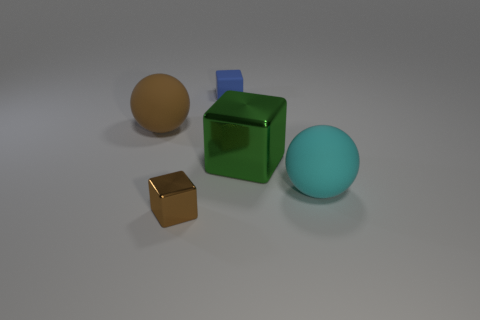Subtract all spheres. How many objects are left? 3 Subtract 1 spheres. How many spheres are left? 1 Subtract all yellow blocks. Subtract all red cylinders. How many blocks are left? 3 Subtract all brown cylinders. How many brown spheres are left? 1 Subtract all matte blocks. Subtract all big cyan blocks. How many objects are left? 4 Add 3 cyan matte balls. How many cyan matte balls are left? 4 Add 3 tiny blue rubber cylinders. How many tiny blue rubber cylinders exist? 3 Add 4 small gray things. How many objects exist? 9 Subtract all cyan spheres. How many spheres are left? 1 Subtract all tiny cubes. How many cubes are left? 1 